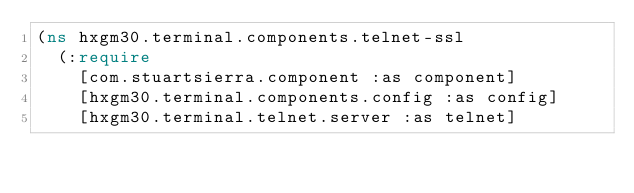<code> <loc_0><loc_0><loc_500><loc_500><_Clojure_>(ns hxgm30.terminal.components.telnet-ssl
  (:require
    [com.stuartsierra.component :as component]
    [hxgm30.terminal.components.config :as config]
    [hxgm30.terminal.telnet.server :as telnet]</code> 